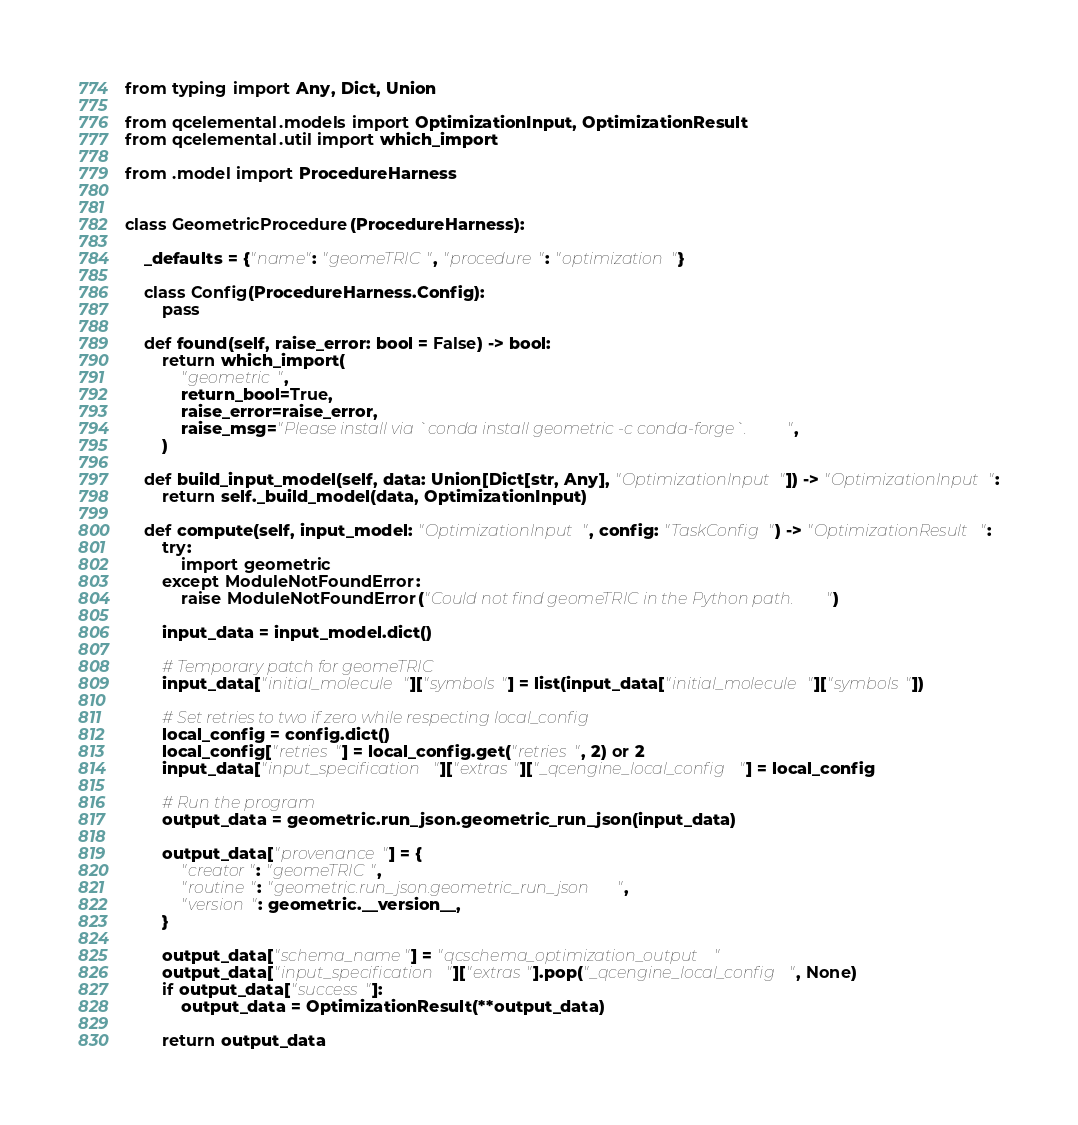Convert code to text. <code><loc_0><loc_0><loc_500><loc_500><_Python_>from typing import Any, Dict, Union

from qcelemental.models import OptimizationInput, OptimizationResult
from qcelemental.util import which_import

from .model import ProcedureHarness


class GeometricProcedure(ProcedureHarness):

    _defaults = {"name": "geomeTRIC", "procedure": "optimization"}

    class Config(ProcedureHarness.Config):
        pass

    def found(self, raise_error: bool = False) -> bool:
        return which_import(
            "geometric",
            return_bool=True,
            raise_error=raise_error,
            raise_msg="Please install via `conda install geometric -c conda-forge`.",
        )

    def build_input_model(self, data: Union[Dict[str, Any], "OptimizationInput"]) -> "OptimizationInput":
        return self._build_model(data, OptimizationInput)

    def compute(self, input_model: "OptimizationInput", config: "TaskConfig") -> "OptimizationResult":
        try:
            import geometric
        except ModuleNotFoundError:
            raise ModuleNotFoundError("Could not find geomeTRIC in the Python path.")

        input_data = input_model.dict()

        # Temporary patch for geomeTRIC
        input_data["initial_molecule"]["symbols"] = list(input_data["initial_molecule"]["symbols"])

        # Set retries to two if zero while respecting local_config
        local_config = config.dict()
        local_config["retries"] = local_config.get("retries", 2) or 2
        input_data["input_specification"]["extras"]["_qcengine_local_config"] = local_config

        # Run the program
        output_data = geometric.run_json.geometric_run_json(input_data)

        output_data["provenance"] = {
            "creator": "geomeTRIC",
            "routine": "geometric.run_json.geometric_run_json",
            "version": geometric.__version__,
        }

        output_data["schema_name"] = "qcschema_optimization_output"
        output_data["input_specification"]["extras"].pop("_qcengine_local_config", None)
        if output_data["success"]:
            output_data = OptimizationResult(**output_data)

        return output_data
</code> 